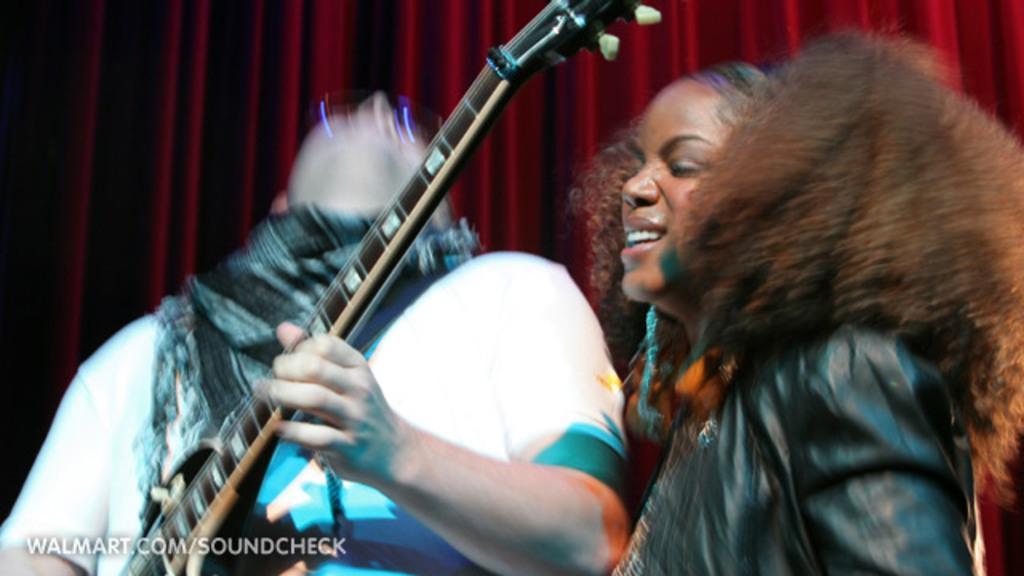Can you describe this image briefly? IN this picture there is a man who is playing the guitar and a woman who is standing at the right side of the image and laughing, there are red color curtains behind the man. 